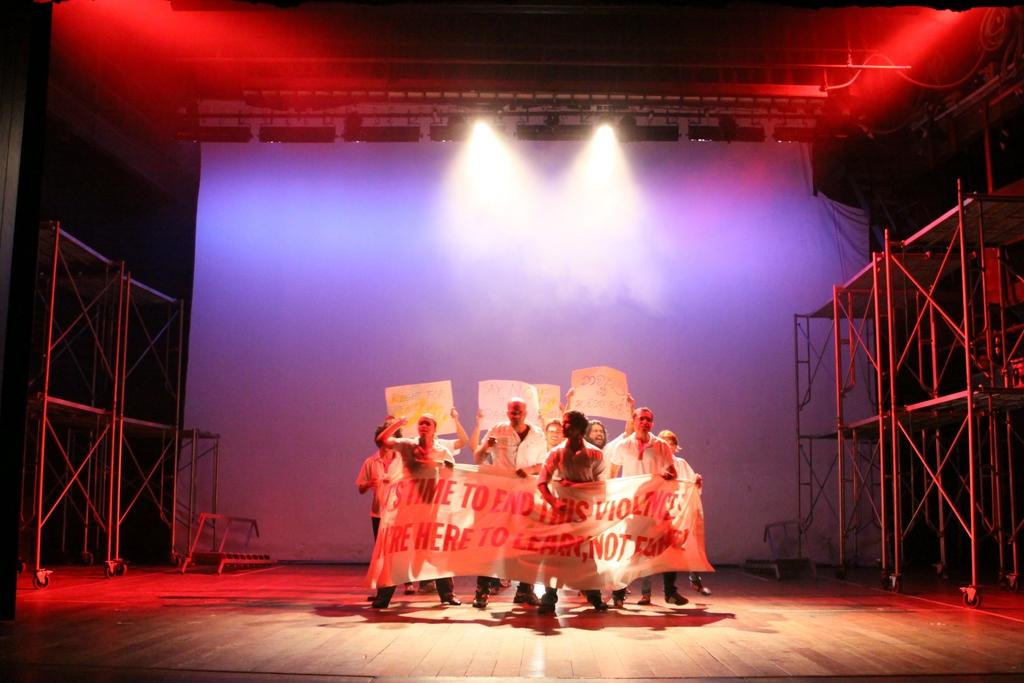What is happening in the image? There is a group of people in the image, and they are standing on a stage. What are the people holding in the image? The people are holding papers in the image. What can be seen hanging above the stage? There is a banner in the image. What type of lighting is present in the image? Focus lights are present in the image. What structural elements can be seen in the image? Iron rods are visible in the image. Are there any other items visible in the image? Yes, there are other items in the image. What type of powder is being used to create the fish sculpture in the image? There is no powder or fish sculpture present in the image. How many glasses are visible on the stage in the image? There are no glasses visible on the stage in the image. 